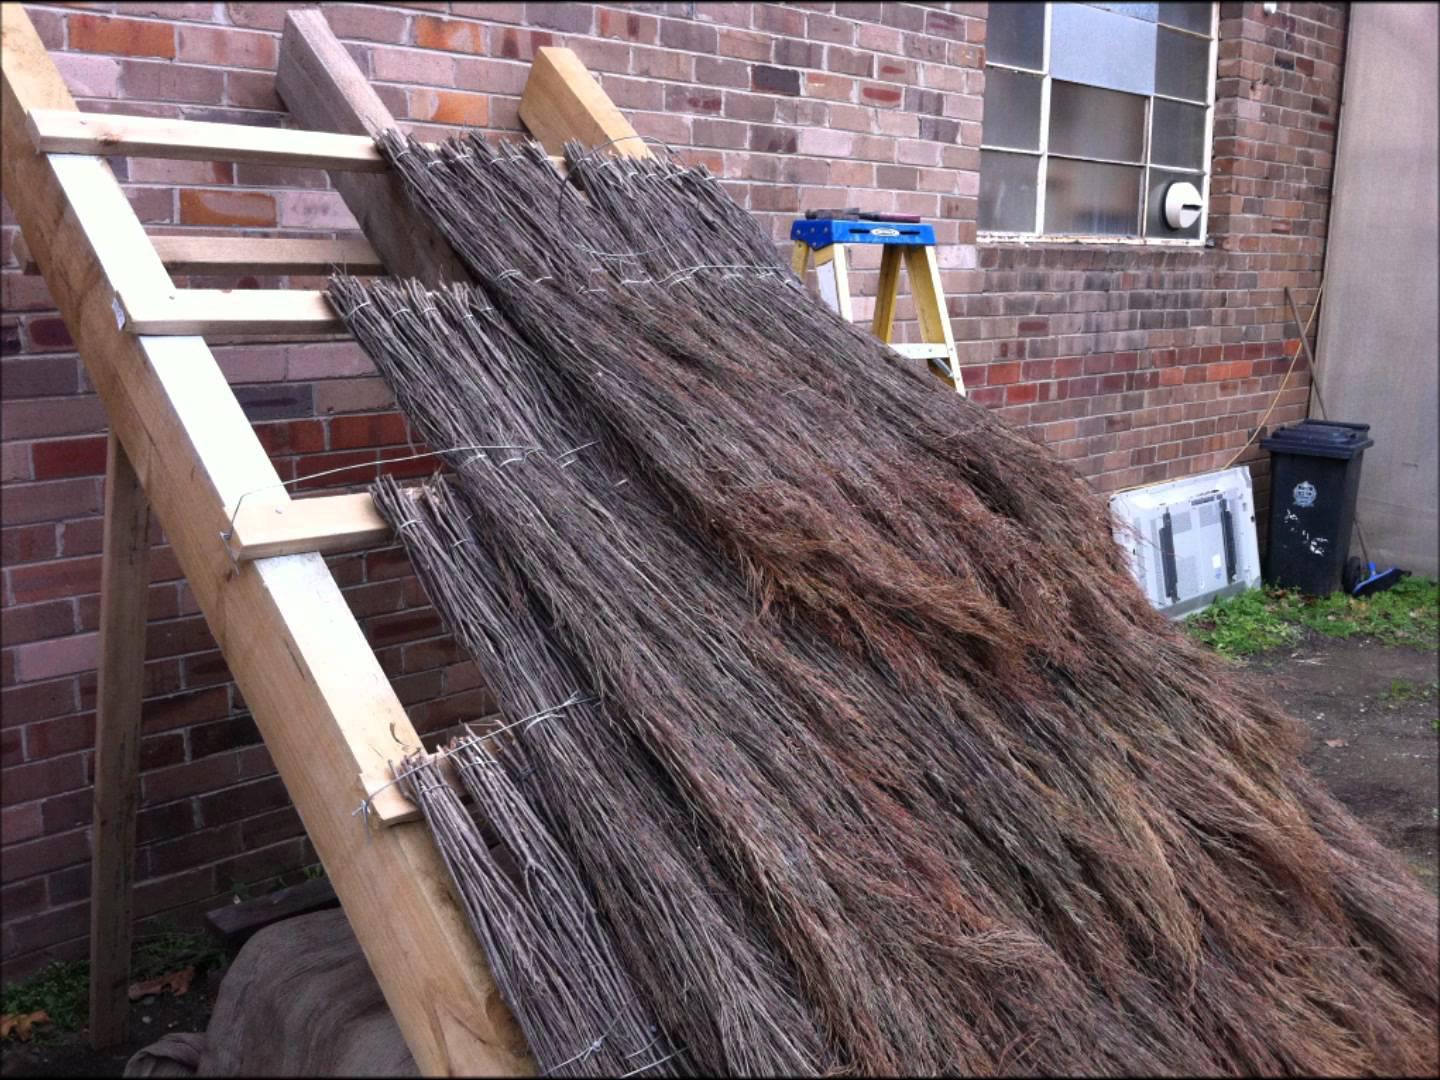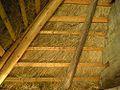The first image is the image on the left, the second image is the image on the right. Analyze the images presented: Is the assertion "An image includes several roll-shaped tied bundles of thatch laying on an unfinished roof without a ladder propped against it." valid? Answer yes or no. No. The first image is the image on the left, the second image is the image on the right. Assess this claim about the two images: "At least one ladder is touching the thatch.". Correct or not? Answer yes or no. Yes. 